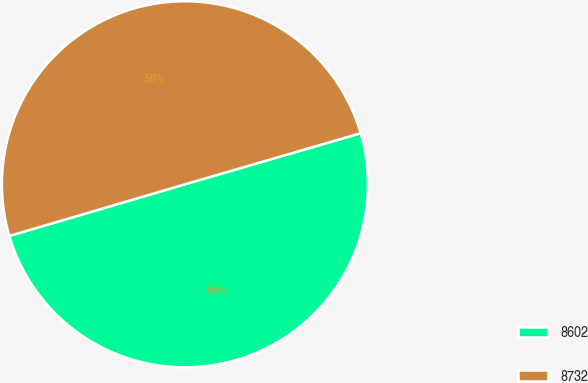Convert chart. <chart><loc_0><loc_0><loc_500><loc_500><pie_chart><fcel>8602<fcel>8732<nl><fcel>49.95%<fcel>50.05%<nl></chart> 